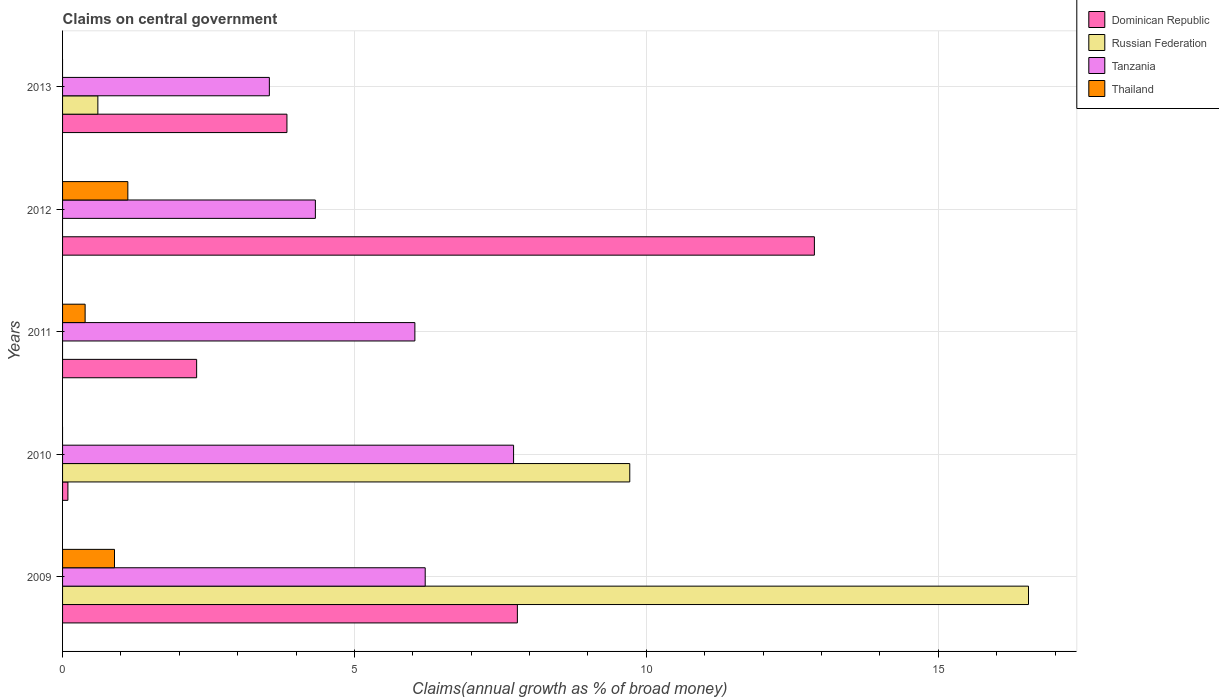How many bars are there on the 3rd tick from the top?
Ensure brevity in your answer.  3. How many bars are there on the 5th tick from the bottom?
Your response must be concise. 3. What is the label of the 1st group of bars from the top?
Offer a terse response. 2013. What is the percentage of broad money claimed on centeral government in Russian Federation in 2010?
Provide a short and direct response. 9.72. Across all years, what is the maximum percentage of broad money claimed on centeral government in Russian Federation?
Give a very brief answer. 16.55. Across all years, what is the minimum percentage of broad money claimed on centeral government in Dominican Republic?
Your response must be concise. 0.09. What is the total percentage of broad money claimed on centeral government in Dominican Republic in the graph?
Keep it short and to the point. 26.9. What is the difference between the percentage of broad money claimed on centeral government in Dominican Republic in 2009 and that in 2010?
Give a very brief answer. 7.7. What is the difference between the percentage of broad money claimed on centeral government in Dominican Republic in 2010 and the percentage of broad money claimed on centeral government in Thailand in 2013?
Provide a short and direct response. 0.09. What is the average percentage of broad money claimed on centeral government in Tanzania per year?
Your response must be concise. 5.57. In the year 2010, what is the difference between the percentage of broad money claimed on centeral government in Tanzania and percentage of broad money claimed on centeral government in Russian Federation?
Your answer should be compact. -1.99. In how many years, is the percentage of broad money claimed on centeral government in Thailand greater than 3 %?
Give a very brief answer. 0. What is the ratio of the percentage of broad money claimed on centeral government in Dominican Republic in 2009 to that in 2012?
Provide a short and direct response. 0.6. Is the percentage of broad money claimed on centeral government in Russian Federation in 2009 less than that in 2010?
Provide a succinct answer. No. What is the difference between the highest and the second highest percentage of broad money claimed on centeral government in Tanzania?
Give a very brief answer. 1.51. What is the difference between the highest and the lowest percentage of broad money claimed on centeral government in Russian Federation?
Make the answer very short. 16.55. In how many years, is the percentage of broad money claimed on centeral government in Dominican Republic greater than the average percentage of broad money claimed on centeral government in Dominican Republic taken over all years?
Your response must be concise. 2. Is it the case that in every year, the sum of the percentage of broad money claimed on centeral government in Dominican Republic and percentage of broad money claimed on centeral government in Tanzania is greater than the sum of percentage of broad money claimed on centeral government in Russian Federation and percentage of broad money claimed on centeral government in Thailand?
Your answer should be very brief. Yes. Are all the bars in the graph horizontal?
Give a very brief answer. Yes. Does the graph contain grids?
Keep it short and to the point. Yes. How many legend labels are there?
Your response must be concise. 4. What is the title of the graph?
Ensure brevity in your answer.  Claims on central government. What is the label or title of the X-axis?
Ensure brevity in your answer.  Claims(annual growth as % of broad money). What is the label or title of the Y-axis?
Offer a very short reply. Years. What is the Claims(annual growth as % of broad money) in Dominican Republic in 2009?
Provide a succinct answer. 7.79. What is the Claims(annual growth as % of broad money) of Russian Federation in 2009?
Your answer should be very brief. 16.55. What is the Claims(annual growth as % of broad money) of Tanzania in 2009?
Your response must be concise. 6.21. What is the Claims(annual growth as % of broad money) in Thailand in 2009?
Offer a terse response. 0.89. What is the Claims(annual growth as % of broad money) of Dominican Republic in 2010?
Offer a terse response. 0.09. What is the Claims(annual growth as % of broad money) in Russian Federation in 2010?
Your answer should be very brief. 9.72. What is the Claims(annual growth as % of broad money) in Tanzania in 2010?
Ensure brevity in your answer.  7.73. What is the Claims(annual growth as % of broad money) of Dominican Republic in 2011?
Offer a very short reply. 2.3. What is the Claims(annual growth as % of broad money) of Russian Federation in 2011?
Provide a short and direct response. 0. What is the Claims(annual growth as % of broad money) in Tanzania in 2011?
Offer a terse response. 6.03. What is the Claims(annual growth as % of broad money) of Thailand in 2011?
Your response must be concise. 0.39. What is the Claims(annual growth as % of broad money) of Dominican Republic in 2012?
Give a very brief answer. 12.88. What is the Claims(annual growth as % of broad money) of Tanzania in 2012?
Your response must be concise. 4.33. What is the Claims(annual growth as % of broad money) of Thailand in 2012?
Your answer should be compact. 1.12. What is the Claims(annual growth as % of broad money) in Dominican Republic in 2013?
Provide a short and direct response. 3.84. What is the Claims(annual growth as % of broad money) of Russian Federation in 2013?
Offer a very short reply. 0.6. What is the Claims(annual growth as % of broad money) of Tanzania in 2013?
Give a very brief answer. 3.54. What is the Claims(annual growth as % of broad money) in Thailand in 2013?
Make the answer very short. 0. Across all years, what is the maximum Claims(annual growth as % of broad money) of Dominican Republic?
Keep it short and to the point. 12.88. Across all years, what is the maximum Claims(annual growth as % of broad money) in Russian Federation?
Make the answer very short. 16.55. Across all years, what is the maximum Claims(annual growth as % of broad money) of Tanzania?
Offer a very short reply. 7.73. Across all years, what is the maximum Claims(annual growth as % of broad money) in Thailand?
Your answer should be compact. 1.12. Across all years, what is the minimum Claims(annual growth as % of broad money) in Dominican Republic?
Your response must be concise. 0.09. Across all years, what is the minimum Claims(annual growth as % of broad money) in Russian Federation?
Your response must be concise. 0. Across all years, what is the minimum Claims(annual growth as % of broad money) of Tanzania?
Keep it short and to the point. 3.54. Across all years, what is the minimum Claims(annual growth as % of broad money) in Thailand?
Ensure brevity in your answer.  0. What is the total Claims(annual growth as % of broad money) in Dominican Republic in the graph?
Make the answer very short. 26.9. What is the total Claims(annual growth as % of broad money) in Russian Federation in the graph?
Give a very brief answer. 26.87. What is the total Claims(annual growth as % of broad money) of Tanzania in the graph?
Keep it short and to the point. 27.84. What is the total Claims(annual growth as % of broad money) of Thailand in the graph?
Provide a short and direct response. 2.39. What is the difference between the Claims(annual growth as % of broad money) in Dominican Republic in 2009 and that in 2010?
Your response must be concise. 7.7. What is the difference between the Claims(annual growth as % of broad money) in Russian Federation in 2009 and that in 2010?
Provide a succinct answer. 6.83. What is the difference between the Claims(annual growth as % of broad money) in Tanzania in 2009 and that in 2010?
Your answer should be compact. -1.51. What is the difference between the Claims(annual growth as % of broad money) in Dominican Republic in 2009 and that in 2011?
Provide a short and direct response. 5.49. What is the difference between the Claims(annual growth as % of broad money) in Tanzania in 2009 and that in 2011?
Provide a short and direct response. 0.18. What is the difference between the Claims(annual growth as % of broad money) in Thailand in 2009 and that in 2011?
Keep it short and to the point. 0.5. What is the difference between the Claims(annual growth as % of broad money) of Dominican Republic in 2009 and that in 2012?
Make the answer very short. -5.09. What is the difference between the Claims(annual growth as % of broad money) in Tanzania in 2009 and that in 2012?
Keep it short and to the point. 1.88. What is the difference between the Claims(annual growth as % of broad money) in Thailand in 2009 and that in 2012?
Give a very brief answer. -0.23. What is the difference between the Claims(annual growth as % of broad money) in Dominican Republic in 2009 and that in 2013?
Provide a short and direct response. 3.95. What is the difference between the Claims(annual growth as % of broad money) of Russian Federation in 2009 and that in 2013?
Your answer should be very brief. 15.94. What is the difference between the Claims(annual growth as % of broad money) in Tanzania in 2009 and that in 2013?
Give a very brief answer. 2.67. What is the difference between the Claims(annual growth as % of broad money) of Dominican Republic in 2010 and that in 2011?
Your answer should be compact. -2.21. What is the difference between the Claims(annual growth as % of broad money) of Tanzania in 2010 and that in 2011?
Your answer should be very brief. 1.69. What is the difference between the Claims(annual growth as % of broad money) of Dominican Republic in 2010 and that in 2012?
Your response must be concise. -12.79. What is the difference between the Claims(annual growth as % of broad money) in Tanzania in 2010 and that in 2012?
Provide a succinct answer. 3.4. What is the difference between the Claims(annual growth as % of broad money) of Dominican Republic in 2010 and that in 2013?
Keep it short and to the point. -3.75. What is the difference between the Claims(annual growth as % of broad money) of Russian Federation in 2010 and that in 2013?
Provide a short and direct response. 9.11. What is the difference between the Claims(annual growth as % of broad money) in Tanzania in 2010 and that in 2013?
Your answer should be very brief. 4.18. What is the difference between the Claims(annual growth as % of broad money) of Dominican Republic in 2011 and that in 2012?
Offer a very short reply. -10.58. What is the difference between the Claims(annual growth as % of broad money) of Tanzania in 2011 and that in 2012?
Your response must be concise. 1.7. What is the difference between the Claims(annual growth as % of broad money) in Thailand in 2011 and that in 2012?
Your answer should be very brief. -0.73. What is the difference between the Claims(annual growth as % of broad money) in Dominican Republic in 2011 and that in 2013?
Provide a short and direct response. -1.55. What is the difference between the Claims(annual growth as % of broad money) in Tanzania in 2011 and that in 2013?
Your response must be concise. 2.49. What is the difference between the Claims(annual growth as % of broad money) of Dominican Republic in 2012 and that in 2013?
Provide a succinct answer. 9.04. What is the difference between the Claims(annual growth as % of broad money) of Tanzania in 2012 and that in 2013?
Offer a very short reply. 0.79. What is the difference between the Claims(annual growth as % of broad money) of Dominican Republic in 2009 and the Claims(annual growth as % of broad money) of Russian Federation in 2010?
Provide a succinct answer. -1.93. What is the difference between the Claims(annual growth as % of broad money) in Dominican Republic in 2009 and the Claims(annual growth as % of broad money) in Tanzania in 2010?
Offer a terse response. 0.07. What is the difference between the Claims(annual growth as % of broad money) in Russian Federation in 2009 and the Claims(annual growth as % of broad money) in Tanzania in 2010?
Your answer should be very brief. 8.82. What is the difference between the Claims(annual growth as % of broad money) of Dominican Republic in 2009 and the Claims(annual growth as % of broad money) of Tanzania in 2011?
Provide a succinct answer. 1.76. What is the difference between the Claims(annual growth as % of broad money) of Dominican Republic in 2009 and the Claims(annual growth as % of broad money) of Thailand in 2011?
Your response must be concise. 7.4. What is the difference between the Claims(annual growth as % of broad money) of Russian Federation in 2009 and the Claims(annual growth as % of broad money) of Tanzania in 2011?
Ensure brevity in your answer.  10.51. What is the difference between the Claims(annual growth as % of broad money) in Russian Federation in 2009 and the Claims(annual growth as % of broad money) in Thailand in 2011?
Your answer should be compact. 16.16. What is the difference between the Claims(annual growth as % of broad money) of Tanzania in 2009 and the Claims(annual growth as % of broad money) of Thailand in 2011?
Offer a terse response. 5.83. What is the difference between the Claims(annual growth as % of broad money) in Dominican Republic in 2009 and the Claims(annual growth as % of broad money) in Tanzania in 2012?
Provide a succinct answer. 3.46. What is the difference between the Claims(annual growth as % of broad money) of Dominican Republic in 2009 and the Claims(annual growth as % of broad money) of Thailand in 2012?
Ensure brevity in your answer.  6.67. What is the difference between the Claims(annual growth as % of broad money) of Russian Federation in 2009 and the Claims(annual growth as % of broad money) of Tanzania in 2012?
Make the answer very short. 12.22. What is the difference between the Claims(annual growth as % of broad money) of Russian Federation in 2009 and the Claims(annual growth as % of broad money) of Thailand in 2012?
Provide a succinct answer. 15.43. What is the difference between the Claims(annual growth as % of broad money) of Tanzania in 2009 and the Claims(annual growth as % of broad money) of Thailand in 2012?
Keep it short and to the point. 5.09. What is the difference between the Claims(annual growth as % of broad money) of Dominican Republic in 2009 and the Claims(annual growth as % of broad money) of Russian Federation in 2013?
Your response must be concise. 7.19. What is the difference between the Claims(annual growth as % of broad money) in Dominican Republic in 2009 and the Claims(annual growth as % of broad money) in Tanzania in 2013?
Your response must be concise. 4.25. What is the difference between the Claims(annual growth as % of broad money) in Russian Federation in 2009 and the Claims(annual growth as % of broad money) in Tanzania in 2013?
Keep it short and to the point. 13. What is the difference between the Claims(annual growth as % of broad money) in Dominican Republic in 2010 and the Claims(annual growth as % of broad money) in Tanzania in 2011?
Provide a succinct answer. -5.94. What is the difference between the Claims(annual growth as % of broad money) in Dominican Republic in 2010 and the Claims(annual growth as % of broad money) in Thailand in 2011?
Keep it short and to the point. -0.3. What is the difference between the Claims(annual growth as % of broad money) of Russian Federation in 2010 and the Claims(annual growth as % of broad money) of Tanzania in 2011?
Ensure brevity in your answer.  3.68. What is the difference between the Claims(annual growth as % of broad money) of Russian Federation in 2010 and the Claims(annual growth as % of broad money) of Thailand in 2011?
Make the answer very short. 9.33. What is the difference between the Claims(annual growth as % of broad money) in Tanzania in 2010 and the Claims(annual growth as % of broad money) in Thailand in 2011?
Provide a succinct answer. 7.34. What is the difference between the Claims(annual growth as % of broad money) of Dominican Republic in 2010 and the Claims(annual growth as % of broad money) of Tanzania in 2012?
Offer a very short reply. -4.24. What is the difference between the Claims(annual growth as % of broad money) in Dominican Republic in 2010 and the Claims(annual growth as % of broad money) in Thailand in 2012?
Your response must be concise. -1.03. What is the difference between the Claims(annual growth as % of broad money) in Russian Federation in 2010 and the Claims(annual growth as % of broad money) in Tanzania in 2012?
Give a very brief answer. 5.39. What is the difference between the Claims(annual growth as % of broad money) in Russian Federation in 2010 and the Claims(annual growth as % of broad money) in Thailand in 2012?
Your response must be concise. 8.6. What is the difference between the Claims(annual growth as % of broad money) in Tanzania in 2010 and the Claims(annual growth as % of broad money) in Thailand in 2012?
Your response must be concise. 6.61. What is the difference between the Claims(annual growth as % of broad money) of Dominican Republic in 2010 and the Claims(annual growth as % of broad money) of Russian Federation in 2013?
Offer a very short reply. -0.51. What is the difference between the Claims(annual growth as % of broad money) in Dominican Republic in 2010 and the Claims(annual growth as % of broad money) in Tanzania in 2013?
Ensure brevity in your answer.  -3.45. What is the difference between the Claims(annual growth as % of broad money) in Russian Federation in 2010 and the Claims(annual growth as % of broad money) in Tanzania in 2013?
Keep it short and to the point. 6.17. What is the difference between the Claims(annual growth as % of broad money) in Dominican Republic in 2011 and the Claims(annual growth as % of broad money) in Tanzania in 2012?
Your answer should be very brief. -2.03. What is the difference between the Claims(annual growth as % of broad money) in Dominican Republic in 2011 and the Claims(annual growth as % of broad money) in Thailand in 2012?
Keep it short and to the point. 1.18. What is the difference between the Claims(annual growth as % of broad money) of Tanzania in 2011 and the Claims(annual growth as % of broad money) of Thailand in 2012?
Offer a very short reply. 4.92. What is the difference between the Claims(annual growth as % of broad money) in Dominican Republic in 2011 and the Claims(annual growth as % of broad money) in Russian Federation in 2013?
Your answer should be very brief. 1.69. What is the difference between the Claims(annual growth as % of broad money) of Dominican Republic in 2011 and the Claims(annual growth as % of broad money) of Tanzania in 2013?
Keep it short and to the point. -1.25. What is the difference between the Claims(annual growth as % of broad money) in Dominican Republic in 2012 and the Claims(annual growth as % of broad money) in Russian Federation in 2013?
Your answer should be compact. 12.27. What is the difference between the Claims(annual growth as % of broad money) of Dominican Republic in 2012 and the Claims(annual growth as % of broad money) of Tanzania in 2013?
Give a very brief answer. 9.34. What is the average Claims(annual growth as % of broad money) of Dominican Republic per year?
Offer a very short reply. 5.38. What is the average Claims(annual growth as % of broad money) of Russian Federation per year?
Your answer should be very brief. 5.37. What is the average Claims(annual growth as % of broad money) of Tanzania per year?
Keep it short and to the point. 5.57. What is the average Claims(annual growth as % of broad money) in Thailand per year?
Offer a very short reply. 0.48. In the year 2009, what is the difference between the Claims(annual growth as % of broad money) in Dominican Republic and Claims(annual growth as % of broad money) in Russian Federation?
Make the answer very short. -8.76. In the year 2009, what is the difference between the Claims(annual growth as % of broad money) in Dominican Republic and Claims(annual growth as % of broad money) in Tanzania?
Offer a terse response. 1.58. In the year 2009, what is the difference between the Claims(annual growth as % of broad money) in Dominican Republic and Claims(annual growth as % of broad money) in Thailand?
Keep it short and to the point. 6.9. In the year 2009, what is the difference between the Claims(annual growth as % of broad money) of Russian Federation and Claims(annual growth as % of broad money) of Tanzania?
Your response must be concise. 10.33. In the year 2009, what is the difference between the Claims(annual growth as % of broad money) of Russian Federation and Claims(annual growth as % of broad money) of Thailand?
Your answer should be very brief. 15.66. In the year 2009, what is the difference between the Claims(annual growth as % of broad money) in Tanzania and Claims(annual growth as % of broad money) in Thailand?
Offer a terse response. 5.32. In the year 2010, what is the difference between the Claims(annual growth as % of broad money) in Dominican Republic and Claims(annual growth as % of broad money) in Russian Federation?
Keep it short and to the point. -9.62. In the year 2010, what is the difference between the Claims(annual growth as % of broad money) in Dominican Republic and Claims(annual growth as % of broad money) in Tanzania?
Make the answer very short. -7.63. In the year 2010, what is the difference between the Claims(annual growth as % of broad money) in Russian Federation and Claims(annual growth as % of broad money) in Tanzania?
Ensure brevity in your answer.  1.99. In the year 2011, what is the difference between the Claims(annual growth as % of broad money) of Dominican Republic and Claims(annual growth as % of broad money) of Tanzania?
Provide a short and direct response. -3.74. In the year 2011, what is the difference between the Claims(annual growth as % of broad money) of Dominican Republic and Claims(annual growth as % of broad money) of Thailand?
Make the answer very short. 1.91. In the year 2011, what is the difference between the Claims(annual growth as % of broad money) in Tanzania and Claims(annual growth as % of broad money) in Thailand?
Give a very brief answer. 5.65. In the year 2012, what is the difference between the Claims(annual growth as % of broad money) in Dominican Republic and Claims(annual growth as % of broad money) in Tanzania?
Your response must be concise. 8.55. In the year 2012, what is the difference between the Claims(annual growth as % of broad money) in Dominican Republic and Claims(annual growth as % of broad money) in Thailand?
Provide a succinct answer. 11.76. In the year 2012, what is the difference between the Claims(annual growth as % of broad money) in Tanzania and Claims(annual growth as % of broad money) in Thailand?
Your response must be concise. 3.21. In the year 2013, what is the difference between the Claims(annual growth as % of broad money) in Dominican Republic and Claims(annual growth as % of broad money) in Russian Federation?
Your answer should be very brief. 3.24. In the year 2013, what is the difference between the Claims(annual growth as % of broad money) in Dominican Republic and Claims(annual growth as % of broad money) in Tanzania?
Offer a terse response. 0.3. In the year 2013, what is the difference between the Claims(annual growth as % of broad money) of Russian Federation and Claims(annual growth as % of broad money) of Tanzania?
Keep it short and to the point. -2.94. What is the ratio of the Claims(annual growth as % of broad money) of Dominican Republic in 2009 to that in 2010?
Your answer should be very brief. 85.27. What is the ratio of the Claims(annual growth as % of broad money) of Russian Federation in 2009 to that in 2010?
Provide a short and direct response. 1.7. What is the ratio of the Claims(annual growth as % of broad money) in Tanzania in 2009 to that in 2010?
Offer a very short reply. 0.8. What is the ratio of the Claims(annual growth as % of broad money) of Dominican Republic in 2009 to that in 2011?
Give a very brief answer. 3.39. What is the ratio of the Claims(annual growth as % of broad money) in Tanzania in 2009 to that in 2011?
Your answer should be compact. 1.03. What is the ratio of the Claims(annual growth as % of broad money) of Thailand in 2009 to that in 2011?
Offer a terse response. 2.3. What is the ratio of the Claims(annual growth as % of broad money) of Dominican Republic in 2009 to that in 2012?
Provide a short and direct response. 0.6. What is the ratio of the Claims(annual growth as % of broad money) of Tanzania in 2009 to that in 2012?
Your answer should be compact. 1.43. What is the ratio of the Claims(annual growth as % of broad money) of Thailand in 2009 to that in 2012?
Make the answer very short. 0.8. What is the ratio of the Claims(annual growth as % of broad money) of Dominican Republic in 2009 to that in 2013?
Make the answer very short. 2.03. What is the ratio of the Claims(annual growth as % of broad money) in Russian Federation in 2009 to that in 2013?
Give a very brief answer. 27.37. What is the ratio of the Claims(annual growth as % of broad money) in Tanzania in 2009 to that in 2013?
Your answer should be very brief. 1.75. What is the ratio of the Claims(annual growth as % of broad money) in Dominican Republic in 2010 to that in 2011?
Make the answer very short. 0.04. What is the ratio of the Claims(annual growth as % of broad money) of Tanzania in 2010 to that in 2011?
Make the answer very short. 1.28. What is the ratio of the Claims(annual growth as % of broad money) in Dominican Republic in 2010 to that in 2012?
Ensure brevity in your answer.  0.01. What is the ratio of the Claims(annual growth as % of broad money) of Tanzania in 2010 to that in 2012?
Your answer should be compact. 1.78. What is the ratio of the Claims(annual growth as % of broad money) in Dominican Republic in 2010 to that in 2013?
Your answer should be compact. 0.02. What is the ratio of the Claims(annual growth as % of broad money) of Russian Federation in 2010 to that in 2013?
Give a very brief answer. 16.07. What is the ratio of the Claims(annual growth as % of broad money) of Tanzania in 2010 to that in 2013?
Your answer should be very brief. 2.18. What is the ratio of the Claims(annual growth as % of broad money) of Dominican Republic in 2011 to that in 2012?
Ensure brevity in your answer.  0.18. What is the ratio of the Claims(annual growth as % of broad money) of Tanzania in 2011 to that in 2012?
Provide a succinct answer. 1.39. What is the ratio of the Claims(annual growth as % of broad money) of Thailand in 2011 to that in 2012?
Ensure brevity in your answer.  0.35. What is the ratio of the Claims(annual growth as % of broad money) in Dominican Republic in 2011 to that in 2013?
Your answer should be very brief. 0.6. What is the ratio of the Claims(annual growth as % of broad money) of Tanzania in 2011 to that in 2013?
Your answer should be compact. 1.7. What is the ratio of the Claims(annual growth as % of broad money) of Dominican Republic in 2012 to that in 2013?
Your answer should be compact. 3.35. What is the ratio of the Claims(annual growth as % of broad money) of Tanzania in 2012 to that in 2013?
Offer a very short reply. 1.22. What is the difference between the highest and the second highest Claims(annual growth as % of broad money) of Dominican Republic?
Give a very brief answer. 5.09. What is the difference between the highest and the second highest Claims(annual growth as % of broad money) in Russian Federation?
Provide a succinct answer. 6.83. What is the difference between the highest and the second highest Claims(annual growth as % of broad money) in Tanzania?
Your answer should be very brief. 1.51. What is the difference between the highest and the second highest Claims(annual growth as % of broad money) of Thailand?
Offer a very short reply. 0.23. What is the difference between the highest and the lowest Claims(annual growth as % of broad money) of Dominican Republic?
Make the answer very short. 12.79. What is the difference between the highest and the lowest Claims(annual growth as % of broad money) of Russian Federation?
Make the answer very short. 16.55. What is the difference between the highest and the lowest Claims(annual growth as % of broad money) in Tanzania?
Keep it short and to the point. 4.18. What is the difference between the highest and the lowest Claims(annual growth as % of broad money) in Thailand?
Keep it short and to the point. 1.12. 